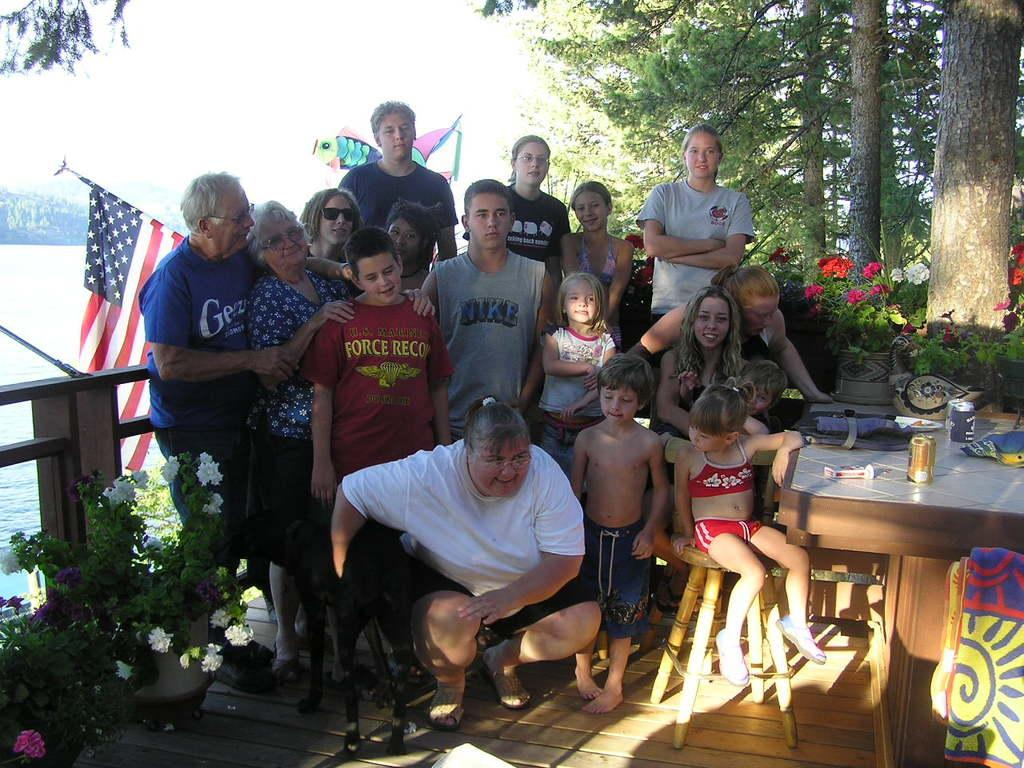How many people are in the image? There is a group of people in the image, but the exact number cannot be determined from the provided facts. What type of animal is in the image? There is a dog in the image. What is the plant in the image? There is a plant in the image, but its specific type cannot be determined from the provided facts. What is the table used for in the image? There is a table in the image, and things are placed on it, suggesting it is being used for support or display. What type of cannon is being fired in the image? There is no cannon present in the image. What type of linen is draped over the table in the image? There is no linen draped over the table in the image. 